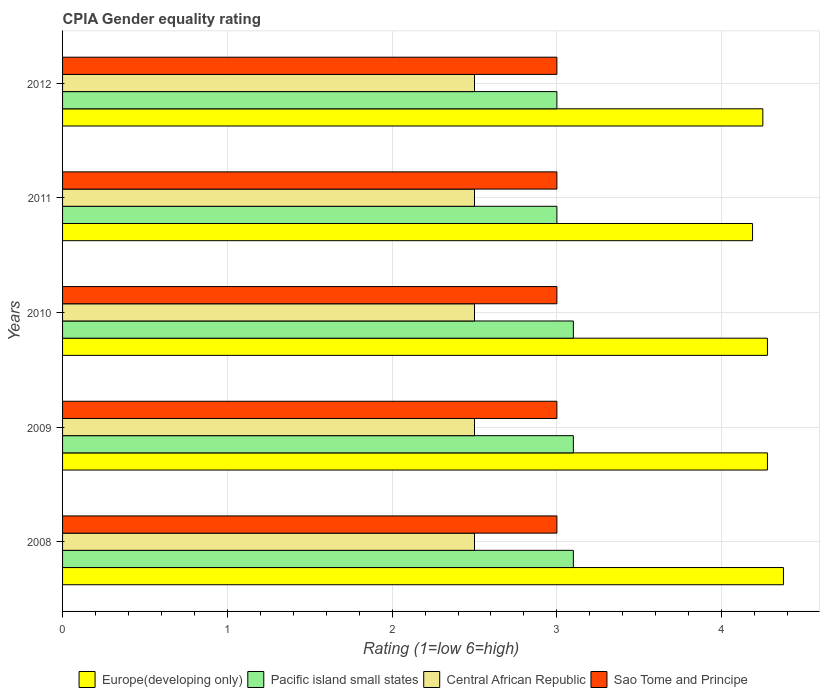How many different coloured bars are there?
Your answer should be very brief. 4. How many groups of bars are there?
Your answer should be very brief. 5. Are the number of bars per tick equal to the number of legend labels?
Offer a very short reply. Yes. Are the number of bars on each tick of the Y-axis equal?
Keep it short and to the point. Yes. What is the label of the 4th group of bars from the top?
Your answer should be very brief. 2009. What is the CPIA rating in Central African Republic in 2009?
Your response must be concise. 2.5. Across all years, what is the maximum CPIA rating in Europe(developing only)?
Give a very brief answer. 4.38. In which year was the CPIA rating in Pacific island small states maximum?
Offer a very short reply. 2008. What is the average CPIA rating in Pacific island small states per year?
Make the answer very short. 3.06. In the year 2008, what is the difference between the CPIA rating in Sao Tome and Principe and CPIA rating in Pacific island small states?
Keep it short and to the point. -0.1. Is the difference between the CPIA rating in Sao Tome and Principe in 2008 and 2009 greater than the difference between the CPIA rating in Pacific island small states in 2008 and 2009?
Provide a short and direct response. No. What is the difference between the highest and the second highest CPIA rating in Pacific island small states?
Provide a succinct answer. 0. Is the sum of the CPIA rating in Central African Republic in 2010 and 2012 greater than the maximum CPIA rating in Pacific island small states across all years?
Keep it short and to the point. Yes. Is it the case that in every year, the sum of the CPIA rating in Europe(developing only) and CPIA rating in Central African Republic is greater than the sum of CPIA rating in Pacific island small states and CPIA rating in Sao Tome and Principe?
Offer a very short reply. Yes. What does the 4th bar from the top in 2008 represents?
Your response must be concise. Europe(developing only). What does the 1st bar from the bottom in 2010 represents?
Your answer should be very brief. Europe(developing only). Is it the case that in every year, the sum of the CPIA rating in Pacific island small states and CPIA rating in Sao Tome and Principe is greater than the CPIA rating in Central African Republic?
Offer a very short reply. Yes. Are all the bars in the graph horizontal?
Provide a succinct answer. Yes. How many years are there in the graph?
Your response must be concise. 5. Are the values on the major ticks of X-axis written in scientific E-notation?
Make the answer very short. No. Where does the legend appear in the graph?
Your answer should be compact. Bottom center. How are the legend labels stacked?
Offer a very short reply. Horizontal. What is the title of the graph?
Your response must be concise. CPIA Gender equality rating. Does "Iraq" appear as one of the legend labels in the graph?
Provide a short and direct response. No. What is the label or title of the X-axis?
Your response must be concise. Rating (1=low 6=high). What is the label or title of the Y-axis?
Provide a succinct answer. Years. What is the Rating (1=low 6=high) of Europe(developing only) in 2008?
Your response must be concise. 4.38. What is the Rating (1=low 6=high) in Pacific island small states in 2008?
Provide a short and direct response. 3.1. What is the Rating (1=low 6=high) of Central African Republic in 2008?
Provide a succinct answer. 2.5. What is the Rating (1=low 6=high) in Sao Tome and Principe in 2008?
Your answer should be very brief. 3. What is the Rating (1=low 6=high) in Europe(developing only) in 2009?
Keep it short and to the point. 4.28. What is the Rating (1=low 6=high) in Pacific island small states in 2009?
Give a very brief answer. 3.1. What is the Rating (1=low 6=high) of Europe(developing only) in 2010?
Keep it short and to the point. 4.28. What is the Rating (1=low 6=high) in Central African Republic in 2010?
Your answer should be very brief. 2.5. What is the Rating (1=low 6=high) of Sao Tome and Principe in 2010?
Your response must be concise. 3. What is the Rating (1=low 6=high) in Europe(developing only) in 2011?
Your response must be concise. 4.19. What is the Rating (1=low 6=high) in Pacific island small states in 2011?
Your answer should be very brief. 3. What is the Rating (1=low 6=high) in Central African Republic in 2011?
Make the answer very short. 2.5. What is the Rating (1=low 6=high) in Sao Tome and Principe in 2011?
Your answer should be very brief. 3. What is the Rating (1=low 6=high) in Europe(developing only) in 2012?
Provide a short and direct response. 4.25. What is the Rating (1=low 6=high) of Central African Republic in 2012?
Your response must be concise. 2.5. Across all years, what is the maximum Rating (1=low 6=high) of Europe(developing only)?
Provide a succinct answer. 4.38. Across all years, what is the maximum Rating (1=low 6=high) of Pacific island small states?
Ensure brevity in your answer.  3.1. Across all years, what is the maximum Rating (1=low 6=high) of Sao Tome and Principe?
Offer a terse response. 3. Across all years, what is the minimum Rating (1=low 6=high) in Europe(developing only)?
Provide a succinct answer. 4.19. Across all years, what is the minimum Rating (1=low 6=high) of Central African Republic?
Provide a short and direct response. 2.5. What is the total Rating (1=low 6=high) of Europe(developing only) in the graph?
Give a very brief answer. 21.37. What is the total Rating (1=low 6=high) in Central African Republic in the graph?
Provide a short and direct response. 12.5. What is the difference between the Rating (1=low 6=high) of Europe(developing only) in 2008 and that in 2009?
Give a very brief answer. 0.1. What is the difference between the Rating (1=low 6=high) of Pacific island small states in 2008 and that in 2009?
Keep it short and to the point. 0. What is the difference between the Rating (1=low 6=high) of Central African Republic in 2008 and that in 2009?
Give a very brief answer. 0. What is the difference between the Rating (1=low 6=high) in Sao Tome and Principe in 2008 and that in 2009?
Keep it short and to the point. 0. What is the difference between the Rating (1=low 6=high) of Europe(developing only) in 2008 and that in 2010?
Your response must be concise. 0.1. What is the difference between the Rating (1=low 6=high) in Pacific island small states in 2008 and that in 2010?
Ensure brevity in your answer.  0. What is the difference between the Rating (1=low 6=high) of Europe(developing only) in 2008 and that in 2011?
Ensure brevity in your answer.  0.19. What is the difference between the Rating (1=low 6=high) of Pacific island small states in 2008 and that in 2011?
Ensure brevity in your answer.  0.1. What is the difference between the Rating (1=low 6=high) of Central African Republic in 2008 and that in 2011?
Your answer should be compact. 0. What is the difference between the Rating (1=low 6=high) of Sao Tome and Principe in 2008 and that in 2011?
Offer a terse response. 0. What is the difference between the Rating (1=low 6=high) of Europe(developing only) in 2008 and that in 2012?
Keep it short and to the point. 0.12. What is the difference between the Rating (1=low 6=high) in Central African Republic in 2008 and that in 2012?
Your answer should be very brief. 0. What is the difference between the Rating (1=low 6=high) in Sao Tome and Principe in 2008 and that in 2012?
Your answer should be very brief. 0. What is the difference between the Rating (1=low 6=high) of Europe(developing only) in 2009 and that in 2010?
Provide a succinct answer. 0. What is the difference between the Rating (1=low 6=high) in Pacific island small states in 2009 and that in 2010?
Keep it short and to the point. 0. What is the difference between the Rating (1=low 6=high) in Central African Republic in 2009 and that in 2010?
Provide a short and direct response. 0. What is the difference between the Rating (1=low 6=high) in Sao Tome and Principe in 2009 and that in 2010?
Provide a succinct answer. 0. What is the difference between the Rating (1=low 6=high) in Europe(developing only) in 2009 and that in 2011?
Ensure brevity in your answer.  0.09. What is the difference between the Rating (1=low 6=high) in Europe(developing only) in 2009 and that in 2012?
Ensure brevity in your answer.  0.03. What is the difference between the Rating (1=low 6=high) in Pacific island small states in 2009 and that in 2012?
Offer a very short reply. 0.1. What is the difference between the Rating (1=low 6=high) in Central African Republic in 2009 and that in 2012?
Keep it short and to the point. 0. What is the difference between the Rating (1=low 6=high) of Sao Tome and Principe in 2009 and that in 2012?
Your answer should be very brief. 0. What is the difference between the Rating (1=low 6=high) of Europe(developing only) in 2010 and that in 2011?
Provide a short and direct response. 0.09. What is the difference between the Rating (1=low 6=high) of Sao Tome and Principe in 2010 and that in 2011?
Ensure brevity in your answer.  0. What is the difference between the Rating (1=low 6=high) in Europe(developing only) in 2010 and that in 2012?
Provide a short and direct response. 0.03. What is the difference between the Rating (1=low 6=high) of Pacific island small states in 2010 and that in 2012?
Offer a very short reply. 0.1. What is the difference between the Rating (1=low 6=high) of Central African Republic in 2010 and that in 2012?
Ensure brevity in your answer.  0. What is the difference between the Rating (1=low 6=high) of Europe(developing only) in 2011 and that in 2012?
Keep it short and to the point. -0.06. What is the difference between the Rating (1=low 6=high) of Pacific island small states in 2011 and that in 2012?
Provide a succinct answer. 0. What is the difference between the Rating (1=low 6=high) of Sao Tome and Principe in 2011 and that in 2012?
Your response must be concise. 0. What is the difference between the Rating (1=low 6=high) in Europe(developing only) in 2008 and the Rating (1=low 6=high) in Pacific island small states in 2009?
Offer a terse response. 1.27. What is the difference between the Rating (1=low 6=high) in Europe(developing only) in 2008 and the Rating (1=low 6=high) in Central African Republic in 2009?
Give a very brief answer. 1.88. What is the difference between the Rating (1=low 6=high) in Europe(developing only) in 2008 and the Rating (1=low 6=high) in Sao Tome and Principe in 2009?
Offer a very short reply. 1.38. What is the difference between the Rating (1=low 6=high) in Pacific island small states in 2008 and the Rating (1=low 6=high) in Central African Republic in 2009?
Your answer should be compact. 0.6. What is the difference between the Rating (1=low 6=high) in Pacific island small states in 2008 and the Rating (1=low 6=high) in Sao Tome and Principe in 2009?
Your answer should be compact. 0.1. What is the difference between the Rating (1=low 6=high) in Central African Republic in 2008 and the Rating (1=low 6=high) in Sao Tome and Principe in 2009?
Make the answer very short. -0.5. What is the difference between the Rating (1=low 6=high) in Europe(developing only) in 2008 and the Rating (1=low 6=high) in Pacific island small states in 2010?
Your answer should be very brief. 1.27. What is the difference between the Rating (1=low 6=high) of Europe(developing only) in 2008 and the Rating (1=low 6=high) of Central African Republic in 2010?
Ensure brevity in your answer.  1.88. What is the difference between the Rating (1=low 6=high) of Europe(developing only) in 2008 and the Rating (1=low 6=high) of Sao Tome and Principe in 2010?
Make the answer very short. 1.38. What is the difference between the Rating (1=low 6=high) in Pacific island small states in 2008 and the Rating (1=low 6=high) in Sao Tome and Principe in 2010?
Make the answer very short. 0.1. What is the difference between the Rating (1=low 6=high) in Europe(developing only) in 2008 and the Rating (1=low 6=high) in Pacific island small states in 2011?
Offer a terse response. 1.38. What is the difference between the Rating (1=low 6=high) in Europe(developing only) in 2008 and the Rating (1=low 6=high) in Central African Republic in 2011?
Provide a succinct answer. 1.88. What is the difference between the Rating (1=low 6=high) of Europe(developing only) in 2008 and the Rating (1=low 6=high) of Sao Tome and Principe in 2011?
Your answer should be compact. 1.38. What is the difference between the Rating (1=low 6=high) of Central African Republic in 2008 and the Rating (1=low 6=high) of Sao Tome and Principe in 2011?
Give a very brief answer. -0.5. What is the difference between the Rating (1=low 6=high) in Europe(developing only) in 2008 and the Rating (1=low 6=high) in Pacific island small states in 2012?
Provide a short and direct response. 1.38. What is the difference between the Rating (1=low 6=high) of Europe(developing only) in 2008 and the Rating (1=low 6=high) of Central African Republic in 2012?
Make the answer very short. 1.88. What is the difference between the Rating (1=low 6=high) of Europe(developing only) in 2008 and the Rating (1=low 6=high) of Sao Tome and Principe in 2012?
Give a very brief answer. 1.38. What is the difference between the Rating (1=low 6=high) in Pacific island small states in 2008 and the Rating (1=low 6=high) in Sao Tome and Principe in 2012?
Give a very brief answer. 0.1. What is the difference between the Rating (1=low 6=high) of Europe(developing only) in 2009 and the Rating (1=low 6=high) of Pacific island small states in 2010?
Make the answer very short. 1.18. What is the difference between the Rating (1=low 6=high) in Europe(developing only) in 2009 and the Rating (1=low 6=high) in Central African Republic in 2010?
Provide a short and direct response. 1.78. What is the difference between the Rating (1=low 6=high) in Europe(developing only) in 2009 and the Rating (1=low 6=high) in Sao Tome and Principe in 2010?
Keep it short and to the point. 1.28. What is the difference between the Rating (1=low 6=high) in Pacific island small states in 2009 and the Rating (1=low 6=high) in Sao Tome and Principe in 2010?
Provide a short and direct response. 0.1. What is the difference between the Rating (1=low 6=high) in Europe(developing only) in 2009 and the Rating (1=low 6=high) in Pacific island small states in 2011?
Keep it short and to the point. 1.28. What is the difference between the Rating (1=low 6=high) of Europe(developing only) in 2009 and the Rating (1=low 6=high) of Central African Republic in 2011?
Your answer should be very brief. 1.78. What is the difference between the Rating (1=low 6=high) of Europe(developing only) in 2009 and the Rating (1=low 6=high) of Sao Tome and Principe in 2011?
Offer a terse response. 1.28. What is the difference between the Rating (1=low 6=high) of Pacific island small states in 2009 and the Rating (1=low 6=high) of Sao Tome and Principe in 2011?
Provide a short and direct response. 0.1. What is the difference between the Rating (1=low 6=high) of Europe(developing only) in 2009 and the Rating (1=low 6=high) of Pacific island small states in 2012?
Your response must be concise. 1.28. What is the difference between the Rating (1=low 6=high) of Europe(developing only) in 2009 and the Rating (1=low 6=high) of Central African Republic in 2012?
Provide a short and direct response. 1.78. What is the difference between the Rating (1=low 6=high) of Europe(developing only) in 2009 and the Rating (1=low 6=high) of Sao Tome and Principe in 2012?
Provide a short and direct response. 1.28. What is the difference between the Rating (1=low 6=high) in Pacific island small states in 2009 and the Rating (1=low 6=high) in Sao Tome and Principe in 2012?
Offer a very short reply. 0.1. What is the difference between the Rating (1=low 6=high) in Europe(developing only) in 2010 and the Rating (1=low 6=high) in Pacific island small states in 2011?
Your answer should be compact. 1.28. What is the difference between the Rating (1=low 6=high) in Europe(developing only) in 2010 and the Rating (1=low 6=high) in Central African Republic in 2011?
Keep it short and to the point. 1.78. What is the difference between the Rating (1=low 6=high) in Europe(developing only) in 2010 and the Rating (1=low 6=high) in Sao Tome and Principe in 2011?
Offer a terse response. 1.28. What is the difference between the Rating (1=low 6=high) in Pacific island small states in 2010 and the Rating (1=low 6=high) in Central African Republic in 2011?
Provide a succinct answer. 0.6. What is the difference between the Rating (1=low 6=high) of Central African Republic in 2010 and the Rating (1=low 6=high) of Sao Tome and Principe in 2011?
Ensure brevity in your answer.  -0.5. What is the difference between the Rating (1=low 6=high) of Europe(developing only) in 2010 and the Rating (1=low 6=high) of Pacific island small states in 2012?
Give a very brief answer. 1.28. What is the difference between the Rating (1=low 6=high) of Europe(developing only) in 2010 and the Rating (1=low 6=high) of Central African Republic in 2012?
Your answer should be compact. 1.78. What is the difference between the Rating (1=low 6=high) in Europe(developing only) in 2010 and the Rating (1=low 6=high) in Sao Tome and Principe in 2012?
Keep it short and to the point. 1.28. What is the difference between the Rating (1=low 6=high) in Pacific island small states in 2010 and the Rating (1=low 6=high) in Central African Republic in 2012?
Your answer should be very brief. 0.6. What is the difference between the Rating (1=low 6=high) in Central African Republic in 2010 and the Rating (1=low 6=high) in Sao Tome and Principe in 2012?
Give a very brief answer. -0.5. What is the difference between the Rating (1=low 6=high) of Europe(developing only) in 2011 and the Rating (1=low 6=high) of Pacific island small states in 2012?
Offer a very short reply. 1.19. What is the difference between the Rating (1=low 6=high) in Europe(developing only) in 2011 and the Rating (1=low 6=high) in Central African Republic in 2012?
Offer a terse response. 1.69. What is the difference between the Rating (1=low 6=high) of Europe(developing only) in 2011 and the Rating (1=low 6=high) of Sao Tome and Principe in 2012?
Your answer should be very brief. 1.19. What is the difference between the Rating (1=low 6=high) in Pacific island small states in 2011 and the Rating (1=low 6=high) in Central African Republic in 2012?
Offer a very short reply. 0.5. What is the difference between the Rating (1=low 6=high) of Central African Republic in 2011 and the Rating (1=low 6=high) of Sao Tome and Principe in 2012?
Ensure brevity in your answer.  -0.5. What is the average Rating (1=low 6=high) in Europe(developing only) per year?
Offer a very short reply. 4.27. What is the average Rating (1=low 6=high) in Pacific island small states per year?
Your response must be concise. 3.06. What is the average Rating (1=low 6=high) in Central African Republic per year?
Provide a short and direct response. 2.5. What is the average Rating (1=low 6=high) of Sao Tome and Principe per year?
Give a very brief answer. 3. In the year 2008, what is the difference between the Rating (1=low 6=high) of Europe(developing only) and Rating (1=low 6=high) of Pacific island small states?
Ensure brevity in your answer.  1.27. In the year 2008, what is the difference between the Rating (1=low 6=high) in Europe(developing only) and Rating (1=low 6=high) in Central African Republic?
Your answer should be compact. 1.88. In the year 2008, what is the difference between the Rating (1=low 6=high) in Europe(developing only) and Rating (1=low 6=high) in Sao Tome and Principe?
Your answer should be very brief. 1.38. In the year 2008, what is the difference between the Rating (1=low 6=high) of Pacific island small states and Rating (1=low 6=high) of Central African Republic?
Your answer should be very brief. 0.6. In the year 2008, what is the difference between the Rating (1=low 6=high) in Pacific island small states and Rating (1=low 6=high) in Sao Tome and Principe?
Make the answer very short. 0.1. In the year 2009, what is the difference between the Rating (1=low 6=high) in Europe(developing only) and Rating (1=low 6=high) in Pacific island small states?
Ensure brevity in your answer.  1.18. In the year 2009, what is the difference between the Rating (1=low 6=high) of Europe(developing only) and Rating (1=low 6=high) of Central African Republic?
Your response must be concise. 1.78. In the year 2009, what is the difference between the Rating (1=low 6=high) of Europe(developing only) and Rating (1=low 6=high) of Sao Tome and Principe?
Your answer should be compact. 1.28. In the year 2009, what is the difference between the Rating (1=low 6=high) of Pacific island small states and Rating (1=low 6=high) of Central African Republic?
Ensure brevity in your answer.  0.6. In the year 2009, what is the difference between the Rating (1=low 6=high) in Pacific island small states and Rating (1=low 6=high) in Sao Tome and Principe?
Your answer should be compact. 0.1. In the year 2010, what is the difference between the Rating (1=low 6=high) of Europe(developing only) and Rating (1=low 6=high) of Pacific island small states?
Provide a short and direct response. 1.18. In the year 2010, what is the difference between the Rating (1=low 6=high) of Europe(developing only) and Rating (1=low 6=high) of Central African Republic?
Offer a terse response. 1.78. In the year 2010, what is the difference between the Rating (1=low 6=high) of Europe(developing only) and Rating (1=low 6=high) of Sao Tome and Principe?
Provide a short and direct response. 1.28. In the year 2010, what is the difference between the Rating (1=low 6=high) in Pacific island small states and Rating (1=low 6=high) in Sao Tome and Principe?
Offer a terse response. 0.1. In the year 2010, what is the difference between the Rating (1=low 6=high) of Central African Republic and Rating (1=low 6=high) of Sao Tome and Principe?
Your answer should be compact. -0.5. In the year 2011, what is the difference between the Rating (1=low 6=high) of Europe(developing only) and Rating (1=low 6=high) of Pacific island small states?
Offer a terse response. 1.19. In the year 2011, what is the difference between the Rating (1=low 6=high) of Europe(developing only) and Rating (1=low 6=high) of Central African Republic?
Offer a terse response. 1.69. In the year 2011, what is the difference between the Rating (1=low 6=high) in Europe(developing only) and Rating (1=low 6=high) in Sao Tome and Principe?
Make the answer very short. 1.19. In the year 2011, what is the difference between the Rating (1=low 6=high) of Pacific island small states and Rating (1=low 6=high) of Central African Republic?
Give a very brief answer. 0.5. In the year 2011, what is the difference between the Rating (1=low 6=high) of Pacific island small states and Rating (1=low 6=high) of Sao Tome and Principe?
Make the answer very short. 0. In the year 2011, what is the difference between the Rating (1=low 6=high) in Central African Republic and Rating (1=low 6=high) in Sao Tome and Principe?
Your response must be concise. -0.5. In the year 2012, what is the difference between the Rating (1=low 6=high) of Europe(developing only) and Rating (1=low 6=high) of Central African Republic?
Keep it short and to the point. 1.75. What is the ratio of the Rating (1=low 6=high) of Europe(developing only) in 2008 to that in 2009?
Your answer should be very brief. 1.02. What is the ratio of the Rating (1=low 6=high) in Central African Republic in 2008 to that in 2009?
Provide a succinct answer. 1. What is the ratio of the Rating (1=low 6=high) in Europe(developing only) in 2008 to that in 2010?
Your response must be concise. 1.02. What is the ratio of the Rating (1=low 6=high) in Pacific island small states in 2008 to that in 2010?
Provide a succinct answer. 1. What is the ratio of the Rating (1=low 6=high) in Central African Republic in 2008 to that in 2010?
Provide a succinct answer. 1. What is the ratio of the Rating (1=low 6=high) of Europe(developing only) in 2008 to that in 2011?
Give a very brief answer. 1.04. What is the ratio of the Rating (1=low 6=high) in Pacific island small states in 2008 to that in 2011?
Offer a terse response. 1.03. What is the ratio of the Rating (1=low 6=high) of Central African Republic in 2008 to that in 2011?
Offer a very short reply. 1. What is the ratio of the Rating (1=low 6=high) of Sao Tome and Principe in 2008 to that in 2011?
Your response must be concise. 1. What is the ratio of the Rating (1=low 6=high) of Europe(developing only) in 2008 to that in 2012?
Ensure brevity in your answer.  1.03. What is the ratio of the Rating (1=low 6=high) in Pacific island small states in 2008 to that in 2012?
Provide a succinct answer. 1.03. What is the ratio of the Rating (1=low 6=high) of Central African Republic in 2008 to that in 2012?
Offer a very short reply. 1. What is the ratio of the Rating (1=low 6=high) of Europe(developing only) in 2009 to that in 2010?
Offer a very short reply. 1. What is the ratio of the Rating (1=low 6=high) in Pacific island small states in 2009 to that in 2010?
Your response must be concise. 1. What is the ratio of the Rating (1=low 6=high) in Sao Tome and Principe in 2009 to that in 2010?
Your answer should be compact. 1. What is the ratio of the Rating (1=low 6=high) in Europe(developing only) in 2009 to that in 2011?
Offer a terse response. 1.02. What is the ratio of the Rating (1=low 6=high) of Pacific island small states in 2009 to that in 2011?
Offer a terse response. 1.03. What is the ratio of the Rating (1=low 6=high) in Central African Republic in 2009 to that in 2011?
Provide a short and direct response. 1. What is the ratio of the Rating (1=low 6=high) in Sao Tome and Principe in 2009 to that in 2011?
Offer a terse response. 1. What is the ratio of the Rating (1=low 6=high) of Europe(developing only) in 2009 to that in 2012?
Offer a terse response. 1.01. What is the ratio of the Rating (1=low 6=high) in Pacific island small states in 2009 to that in 2012?
Offer a terse response. 1.03. What is the ratio of the Rating (1=low 6=high) of Central African Republic in 2009 to that in 2012?
Ensure brevity in your answer.  1. What is the ratio of the Rating (1=low 6=high) of Europe(developing only) in 2010 to that in 2011?
Your response must be concise. 1.02. What is the ratio of the Rating (1=low 6=high) of Pacific island small states in 2010 to that in 2011?
Provide a succinct answer. 1.03. What is the ratio of the Rating (1=low 6=high) in Sao Tome and Principe in 2010 to that in 2011?
Give a very brief answer. 1. What is the ratio of the Rating (1=low 6=high) of Europe(developing only) in 2010 to that in 2012?
Keep it short and to the point. 1.01. What is the ratio of the Rating (1=low 6=high) in Pacific island small states in 2010 to that in 2012?
Offer a very short reply. 1.03. What is the ratio of the Rating (1=low 6=high) of Central African Republic in 2010 to that in 2012?
Provide a succinct answer. 1. What is the ratio of the Rating (1=low 6=high) of Sao Tome and Principe in 2010 to that in 2012?
Your response must be concise. 1. What is the ratio of the Rating (1=low 6=high) in Europe(developing only) in 2011 to that in 2012?
Give a very brief answer. 0.99. What is the difference between the highest and the second highest Rating (1=low 6=high) in Europe(developing only)?
Make the answer very short. 0.1. What is the difference between the highest and the second highest Rating (1=low 6=high) of Pacific island small states?
Offer a very short reply. 0. What is the difference between the highest and the second highest Rating (1=low 6=high) in Central African Republic?
Your answer should be compact. 0. What is the difference between the highest and the second highest Rating (1=low 6=high) of Sao Tome and Principe?
Offer a very short reply. 0. What is the difference between the highest and the lowest Rating (1=low 6=high) of Europe(developing only)?
Provide a succinct answer. 0.19. What is the difference between the highest and the lowest Rating (1=low 6=high) in Pacific island small states?
Provide a succinct answer. 0.1. What is the difference between the highest and the lowest Rating (1=low 6=high) in Central African Republic?
Provide a short and direct response. 0. What is the difference between the highest and the lowest Rating (1=low 6=high) in Sao Tome and Principe?
Your response must be concise. 0. 